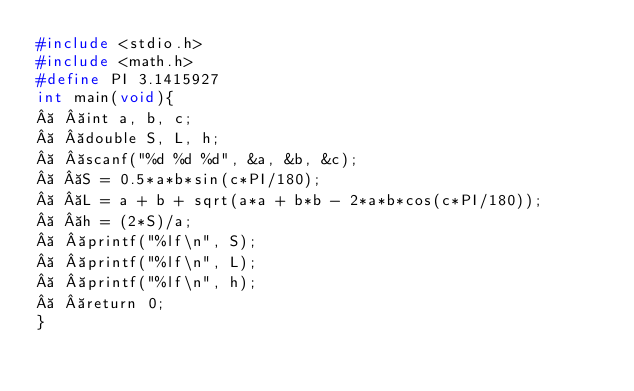<code> <loc_0><loc_0><loc_500><loc_500><_C_>#include <stdio.h>
#include <math.h>
#define PI 3.1415927
int main(void){
   int a, b, c;
   double S, L, h;
   scanf("%d %d %d", &a, &b, &c);
   S = 0.5*a*b*sin(c*PI/180);
   L = a + b + sqrt(a*a + b*b - 2*a*b*cos(c*PI/180));
   h = (2*S)/a;
   printf("%lf\n", S);
   printf("%lf\n", L);
   printf("%lf\n", h);
   return 0;
}
</code> 